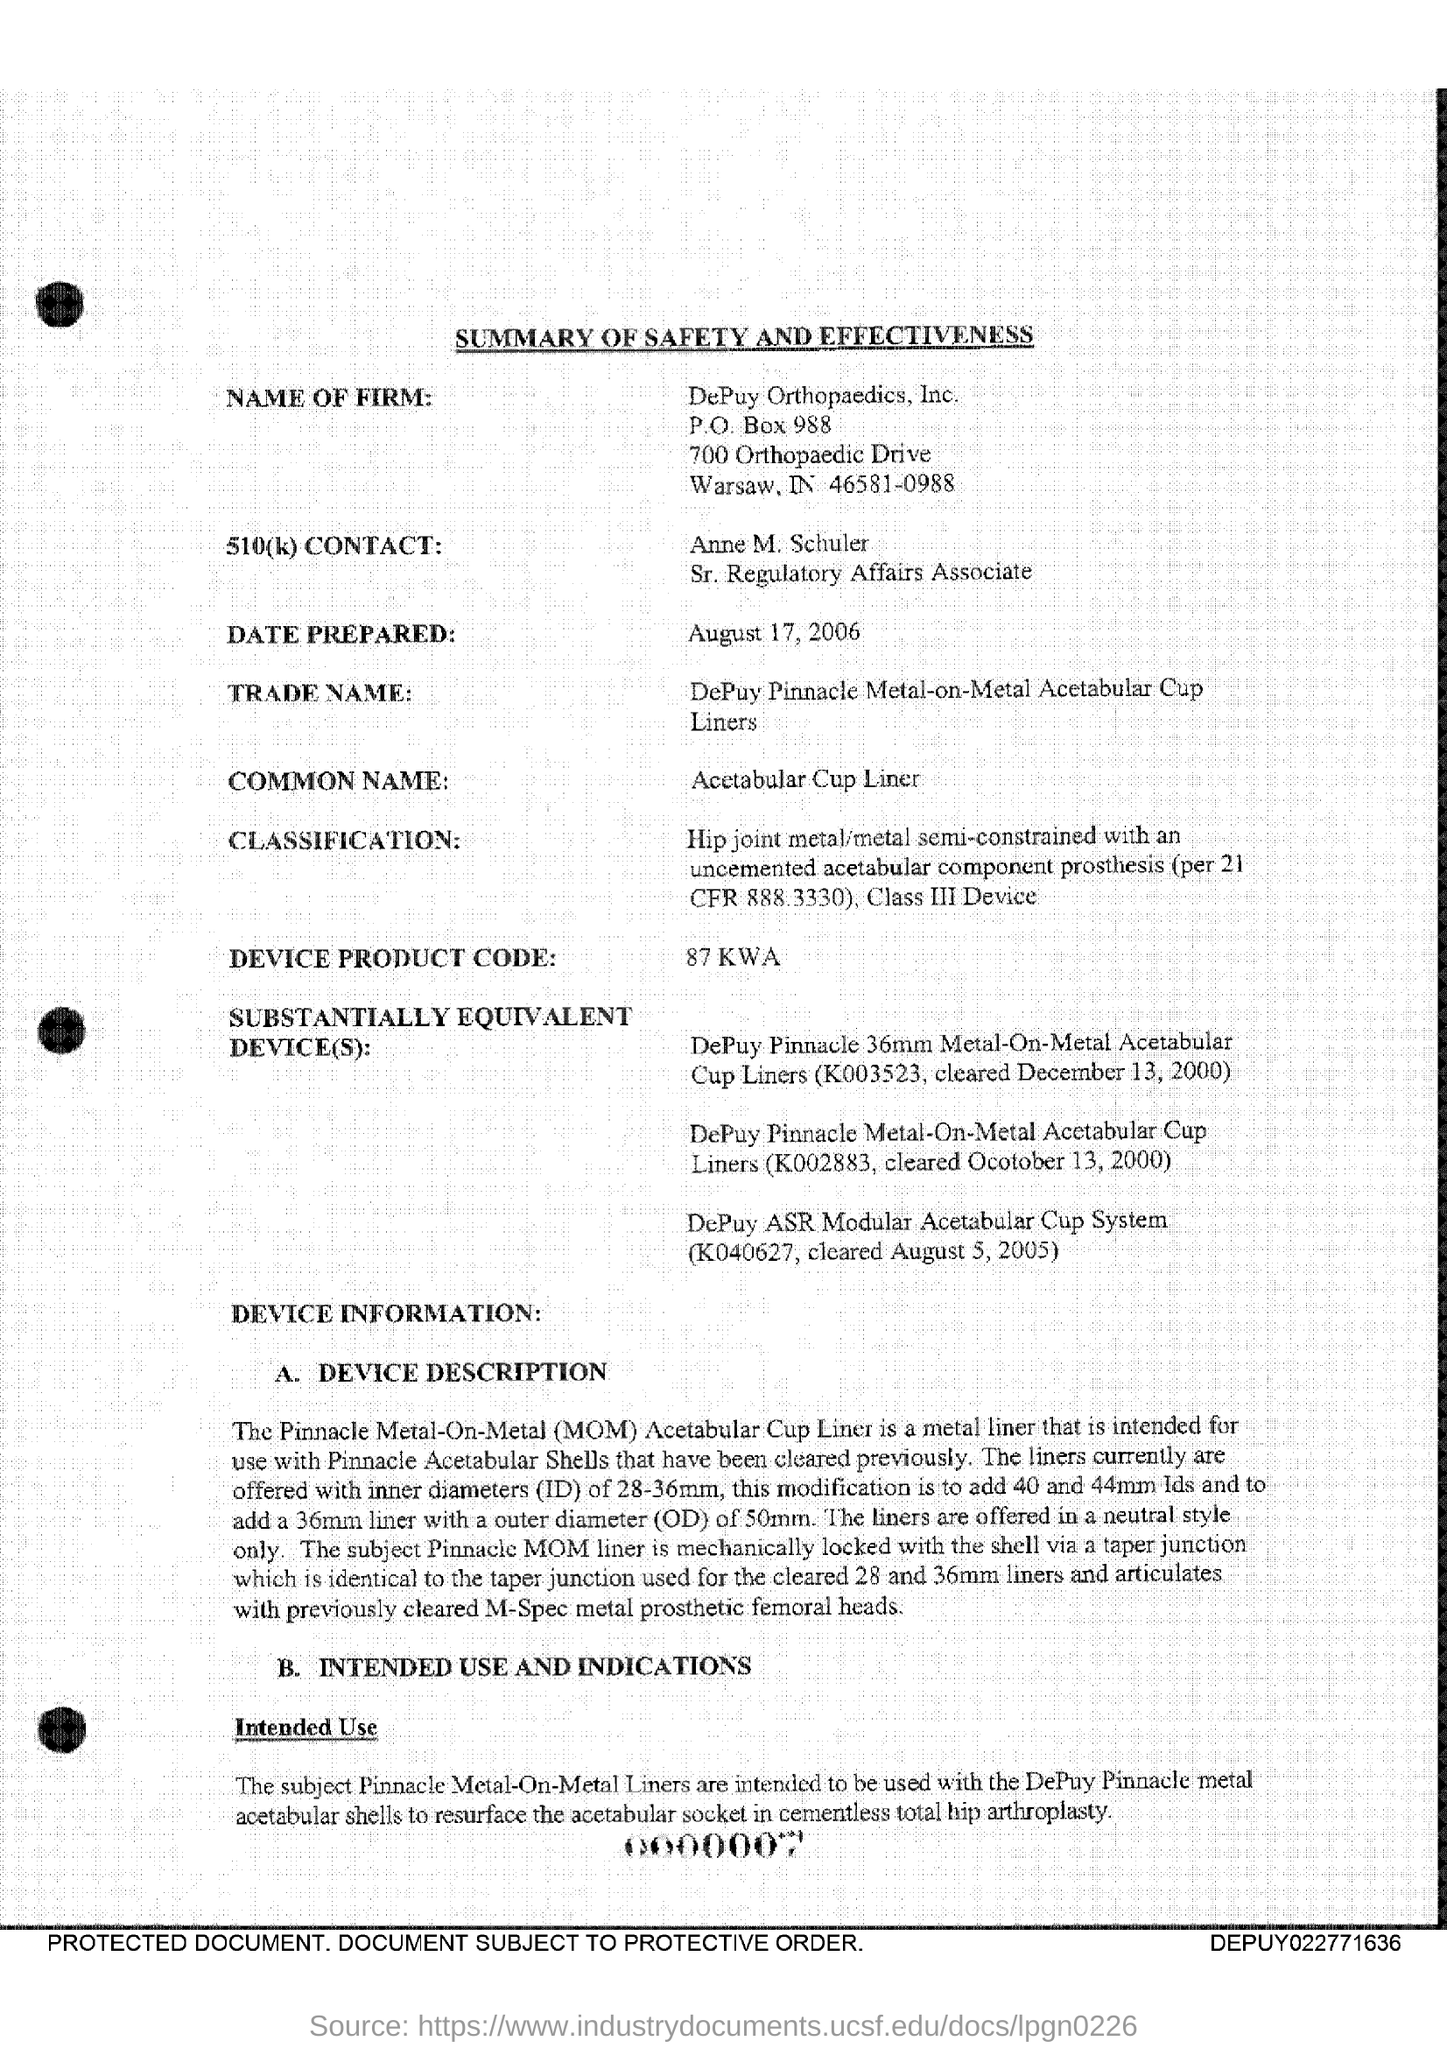In which state is depuy orthopaedics, inc. located?
Provide a short and direct response. IN. What is the po box no. of depuy orthopaedics, inc ?
Keep it short and to the point. 988. What is the position of anne m. schuler ?
Keep it short and to the point. Sr. regulatory affairs associate. What is the common name?
Provide a short and direct response. Acetabular Cup Liner. What does mom stand for ?
Your answer should be very brief. Metal-on-metal. What does id stand for ?
Make the answer very short. Inner diameters. What does od stand for ?
Your answer should be compact. Outer Diameter. 